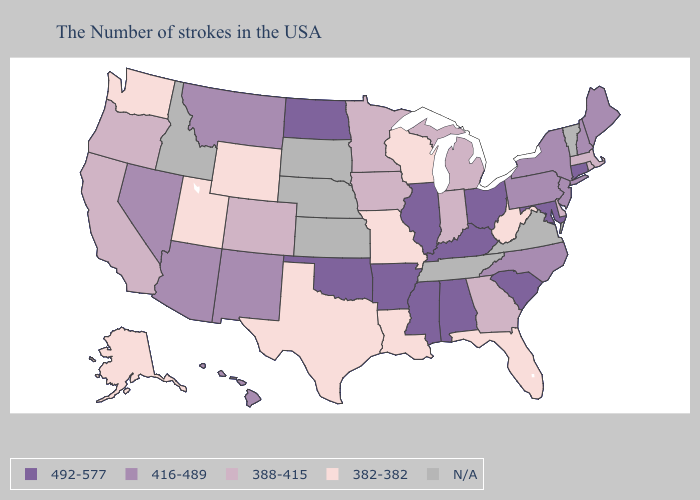Name the states that have a value in the range N/A?
Write a very short answer. Vermont, Virginia, Tennessee, Kansas, Nebraska, South Dakota, Idaho. What is the highest value in states that border Montana?
Concise answer only. 492-577. Does Pennsylvania have the lowest value in the USA?
Short answer required. No. Among the states that border Idaho , which have the highest value?
Give a very brief answer. Montana, Nevada. Name the states that have a value in the range N/A?
Quick response, please. Vermont, Virginia, Tennessee, Kansas, Nebraska, South Dakota, Idaho. What is the value of Idaho?
Write a very short answer. N/A. What is the highest value in states that border South Carolina?
Quick response, please. 416-489. What is the value of Rhode Island?
Quick response, please. 388-415. What is the highest value in states that border Iowa?
Write a very short answer. 492-577. Among the states that border Kentucky , does Ohio have the lowest value?
Give a very brief answer. No. What is the value of Vermont?
Write a very short answer. N/A. Which states have the highest value in the USA?
Write a very short answer. Connecticut, Maryland, South Carolina, Ohio, Kentucky, Alabama, Illinois, Mississippi, Arkansas, Oklahoma, North Dakota. What is the highest value in states that border North Carolina?
Keep it brief. 492-577. Does the first symbol in the legend represent the smallest category?
Quick response, please. No. What is the highest value in the USA?
Give a very brief answer. 492-577. 